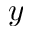<formula> <loc_0><loc_0><loc_500><loc_500>y</formula> 